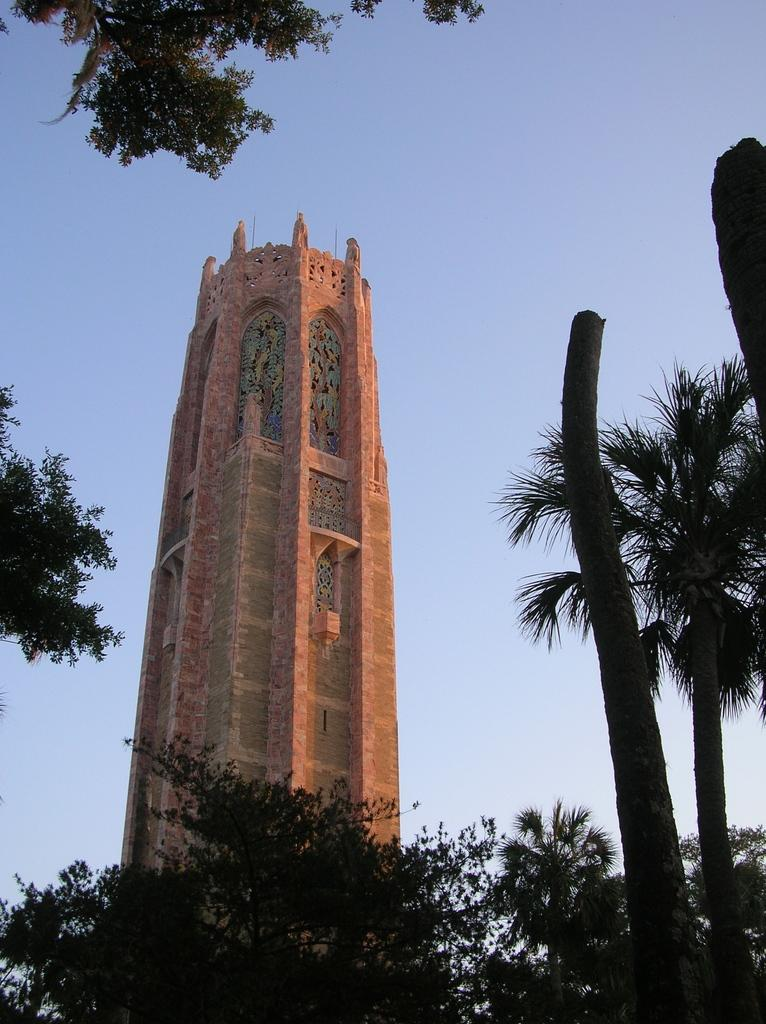What is the main structure in the middle of the image? There is a tower in the middle of the image. What type of vegetation is at the bottom of the image? There are trees at the bottom of the image. What is visible at the top of the image? The sky is visible at the top of the image. How many fish can be seen swimming in the sky in the image? There are no fish visible in the sky in the image. 